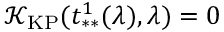<formula> <loc_0><loc_0><loc_500><loc_500>\mathcal { K } _ { K P } ( t _ { * * } ^ { 1 } ( \lambda ) , \lambda ) = 0</formula> 